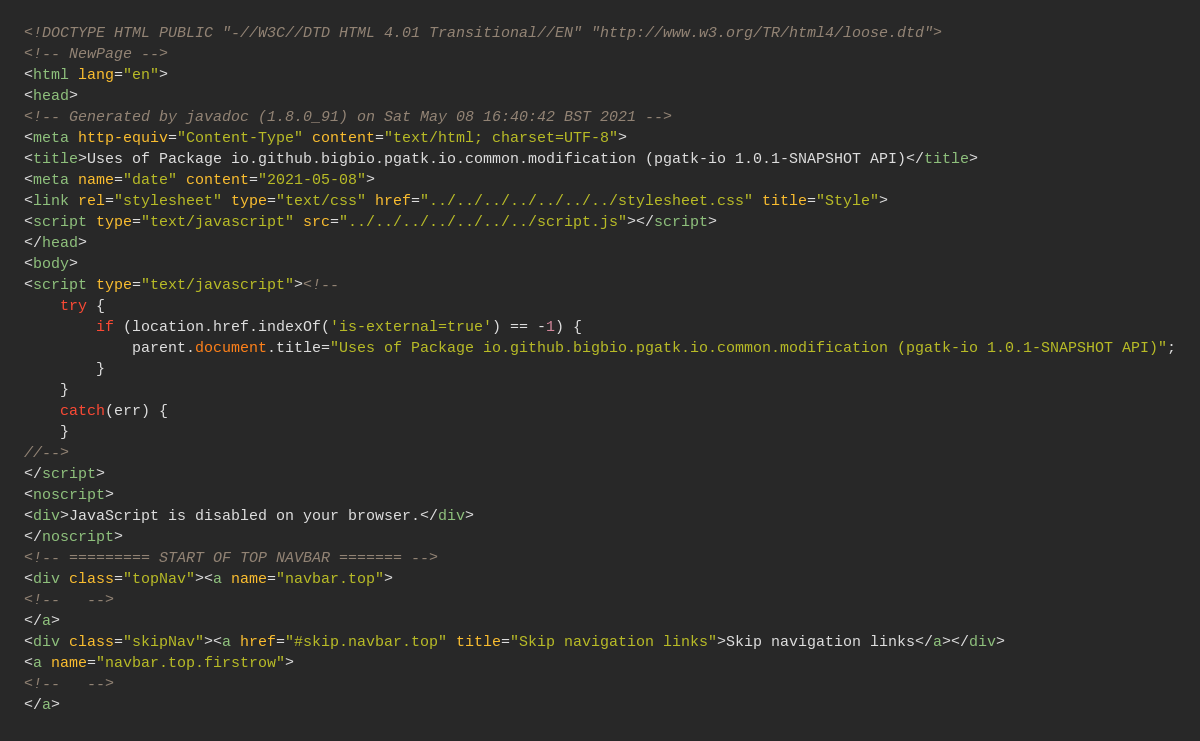Convert code to text. <code><loc_0><loc_0><loc_500><loc_500><_HTML_><!DOCTYPE HTML PUBLIC "-//W3C//DTD HTML 4.01 Transitional//EN" "http://www.w3.org/TR/html4/loose.dtd">
<!-- NewPage -->
<html lang="en">
<head>
<!-- Generated by javadoc (1.8.0_91) on Sat May 08 16:40:42 BST 2021 -->
<meta http-equiv="Content-Type" content="text/html; charset=UTF-8">
<title>Uses of Package io.github.bigbio.pgatk.io.common.modification (pgatk-io 1.0.1-SNAPSHOT API)</title>
<meta name="date" content="2021-05-08">
<link rel="stylesheet" type="text/css" href="../../../../../../../stylesheet.css" title="Style">
<script type="text/javascript" src="../../../../../../../script.js"></script>
</head>
<body>
<script type="text/javascript"><!--
    try {
        if (location.href.indexOf('is-external=true') == -1) {
            parent.document.title="Uses of Package io.github.bigbio.pgatk.io.common.modification (pgatk-io 1.0.1-SNAPSHOT API)";
        }
    }
    catch(err) {
    }
//-->
</script>
<noscript>
<div>JavaScript is disabled on your browser.</div>
</noscript>
<!-- ========= START OF TOP NAVBAR ======= -->
<div class="topNav"><a name="navbar.top">
<!--   -->
</a>
<div class="skipNav"><a href="#skip.navbar.top" title="Skip navigation links">Skip navigation links</a></div>
<a name="navbar.top.firstrow">
<!--   -->
</a></code> 